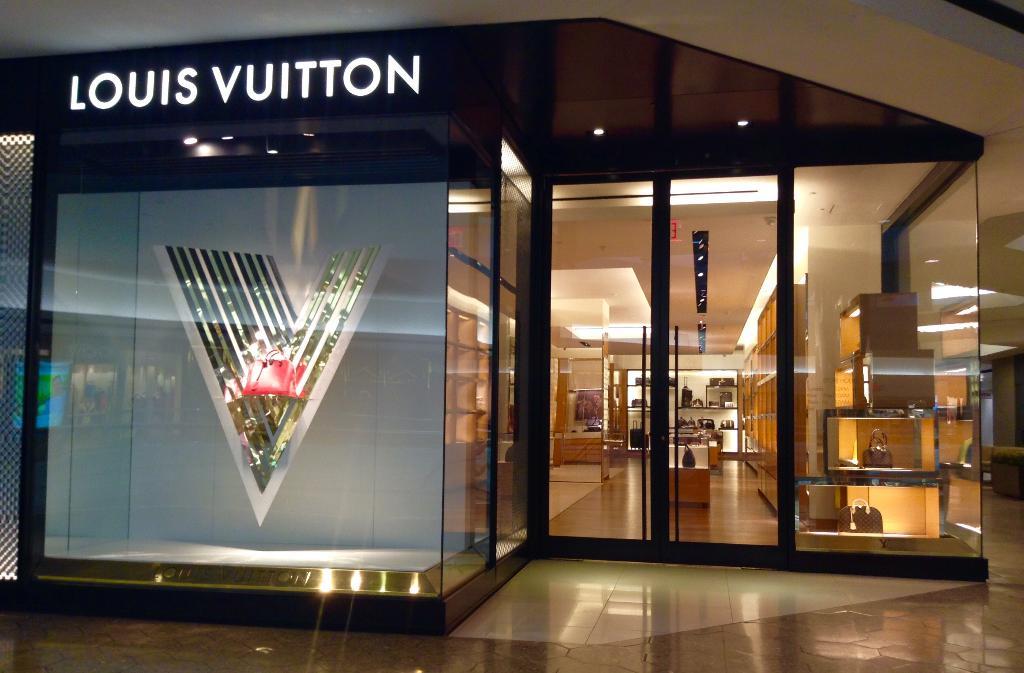What store is this?
Offer a very short reply. Louis vuitton. 